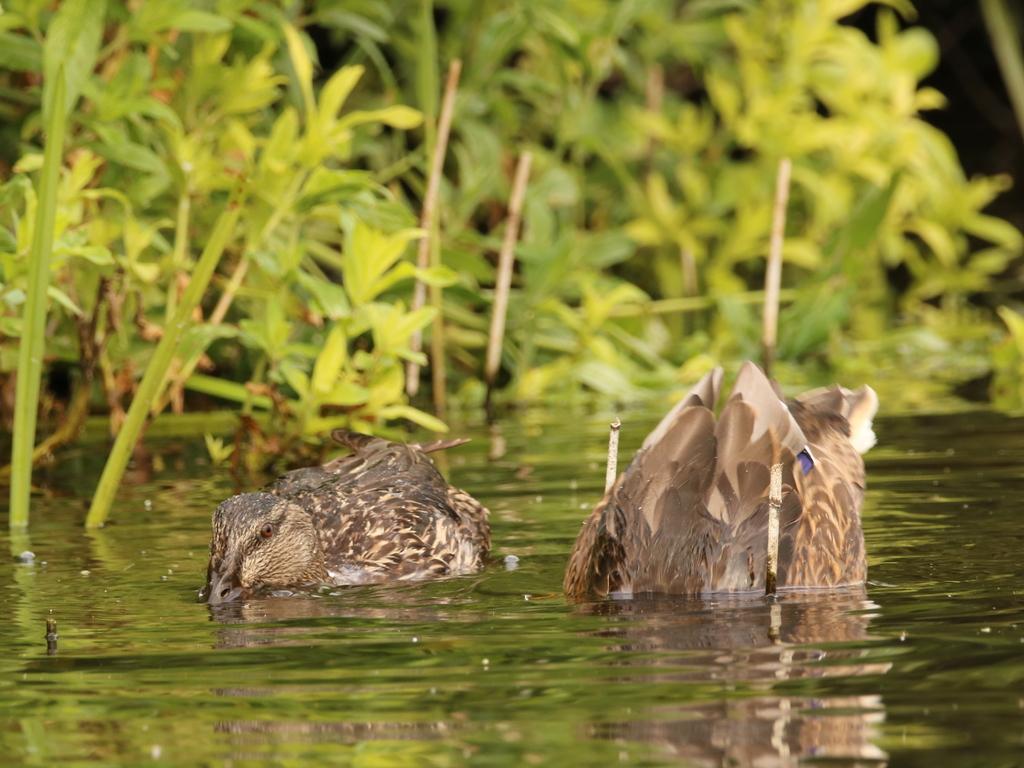Could you give a brief overview of what you see in this image? This picture shows couple of birds swimming in the water and we see plants on the side. 